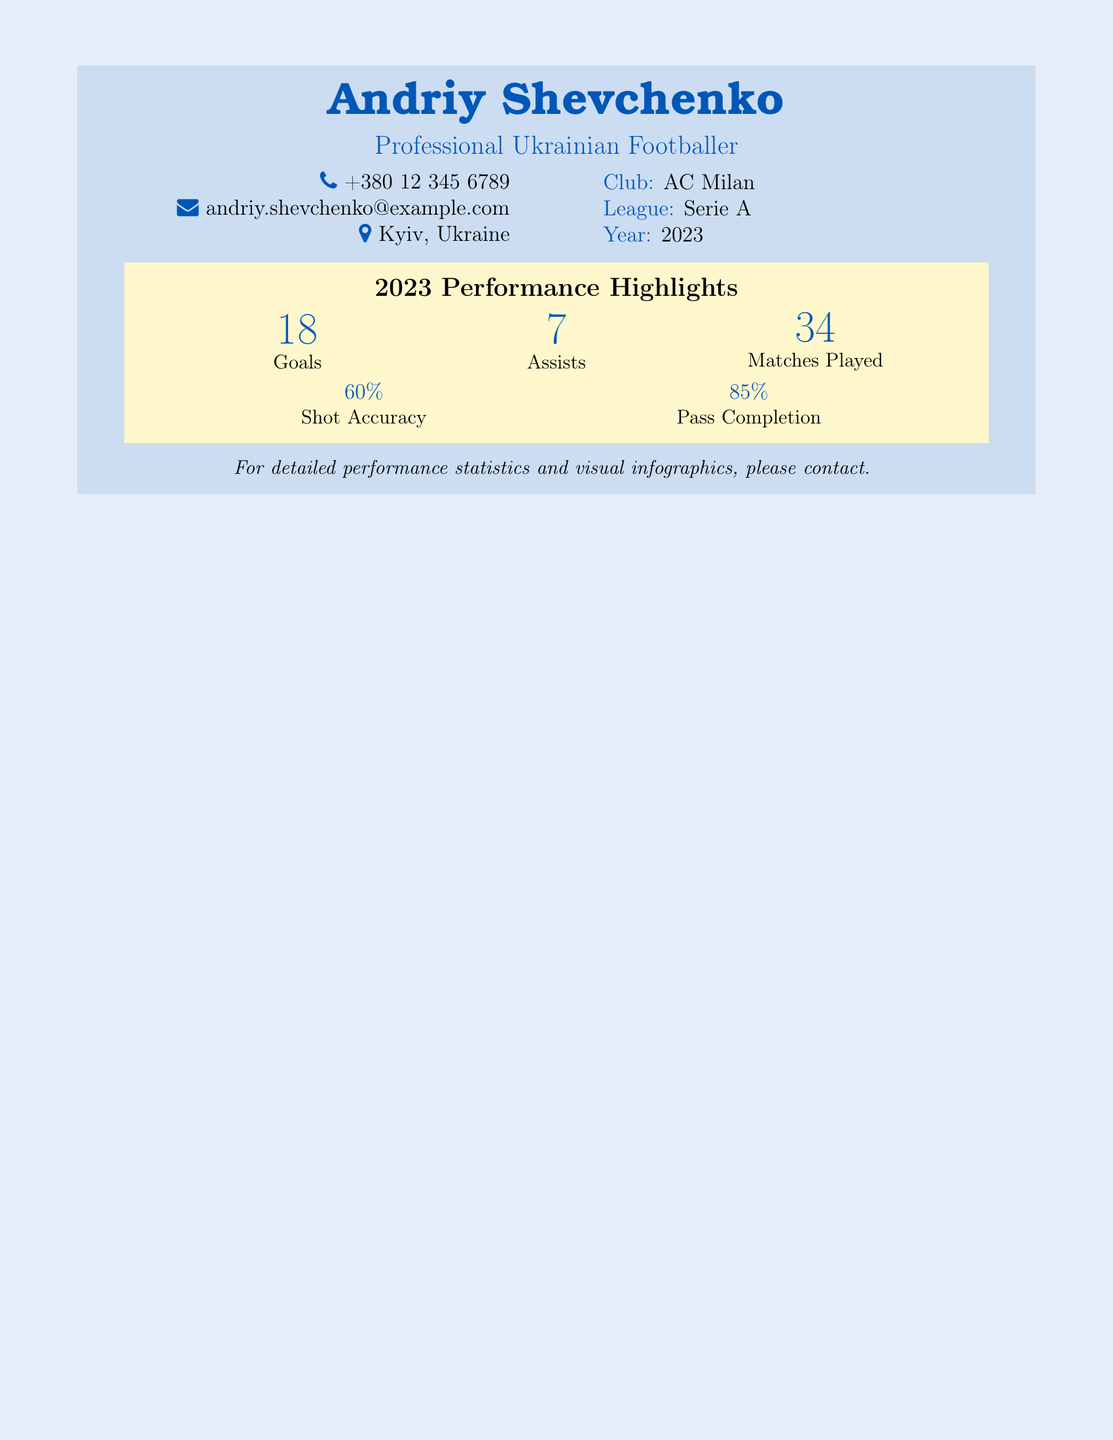what is the name of the player? The name of the player is prominently displayed at the top of the document.
Answer: Andriy Shevchenko what is the club of the player? The club is mentioned in the information section of the document.
Answer: AC Milan how many goals did the player score in 2023? The number of goals is listed under the performance highlights section.
Answer: 18 how many assists did the player have in 2023? The assists are also shown in the performance highlights section of the document.
Answer: 7 how many matches did the player play in 2023? The total matches played are indicated in the performance highlights section.
Answer: 34 what is the player's shot accuracy percentage? The shot accuracy is provided in the performance highlights section of the document.
Answer: 60% what is the player's pass completion percentage? The pass completion percentage is found in the performance highlights section.
Answer: 85% which league is the player currently in? The league is specified in the information section of the document.
Answer: Serie A what year is represented in the performance summary? The year is mentioned under the league section in the document.
Answer: 2023 what type of document is this? The overall structure and content suggest it's a business card focused on performance statistics.
Answer: Business card 